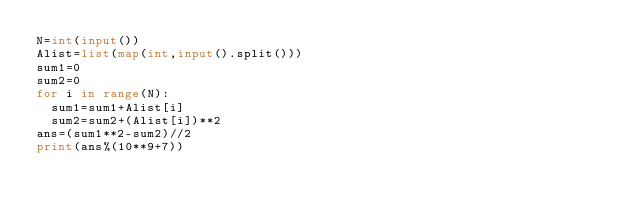Convert code to text. <code><loc_0><loc_0><loc_500><loc_500><_Python_>N=int(input())
Alist=list(map(int,input().split()))
sum1=0
sum2=0
for i in range(N):
  sum1=sum1+Alist[i]
  sum2=sum2+(Alist[i])**2
ans=(sum1**2-sum2)//2
print(ans%(10**9+7))</code> 